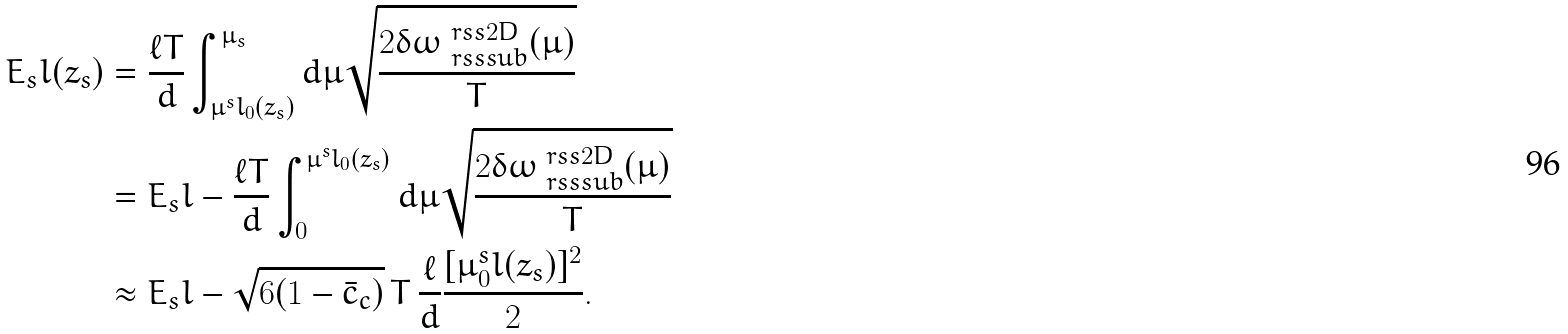<formula> <loc_0><loc_0><loc_500><loc_500>E _ { s } l ( z _ { s } ) & = \frac { \ell T } { d } \int _ { \mu ^ { s } l _ { 0 } ( z _ { s } ) } ^ { \mu _ { s } } d \mu \sqrt { \frac { 2 \delta \omega ^ { \ r s s 2 D } _ { \ r s s s u b } ( \mu ) } { T } } \\ & = E _ { s } l - \frac { \ell T } { d } \int _ { 0 } ^ { \mu ^ { s } l _ { 0 } ( z _ { s } ) } d \mu \sqrt { \frac { 2 \delta \omega ^ { \ r s s 2 D } _ { \ r s s s u b } ( \mu ) } { T } } \\ & \approx E _ { s } l - \sqrt { 6 ( 1 - \bar { c } _ { c } ) } \, T \, \frac { \ell } { d } \frac { [ \mu _ { 0 } ^ { s } l ( z _ { s } ) ] ^ { 2 } } { 2 } .</formula> 